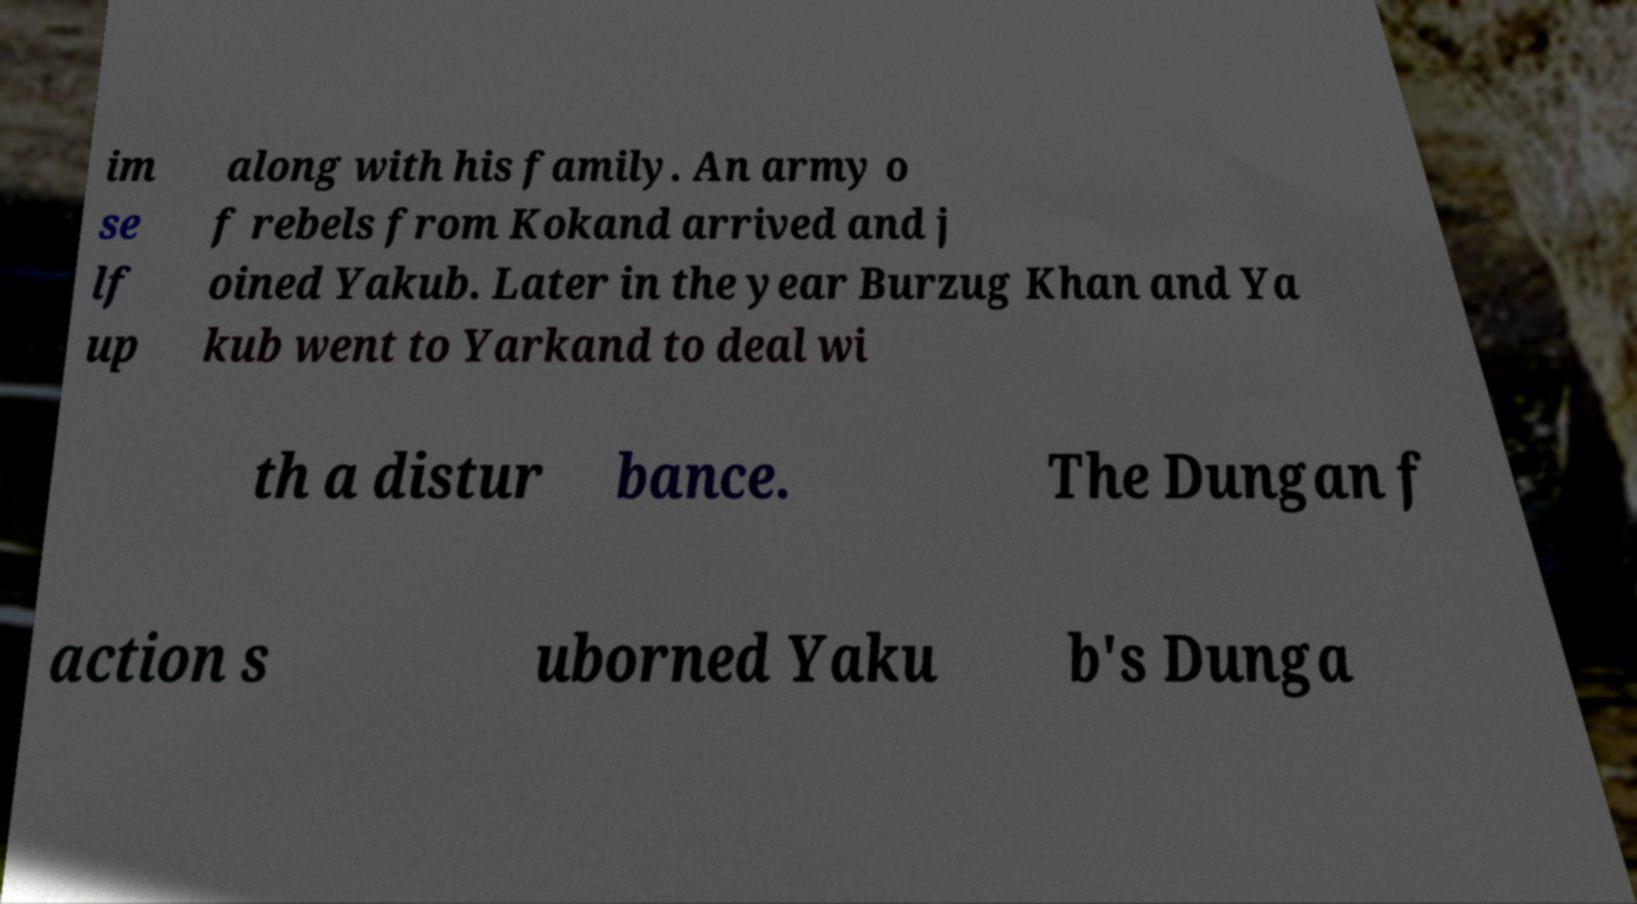Could you assist in decoding the text presented in this image and type it out clearly? im se lf up along with his family. An army o f rebels from Kokand arrived and j oined Yakub. Later in the year Burzug Khan and Ya kub went to Yarkand to deal wi th a distur bance. The Dungan f action s uborned Yaku b's Dunga 